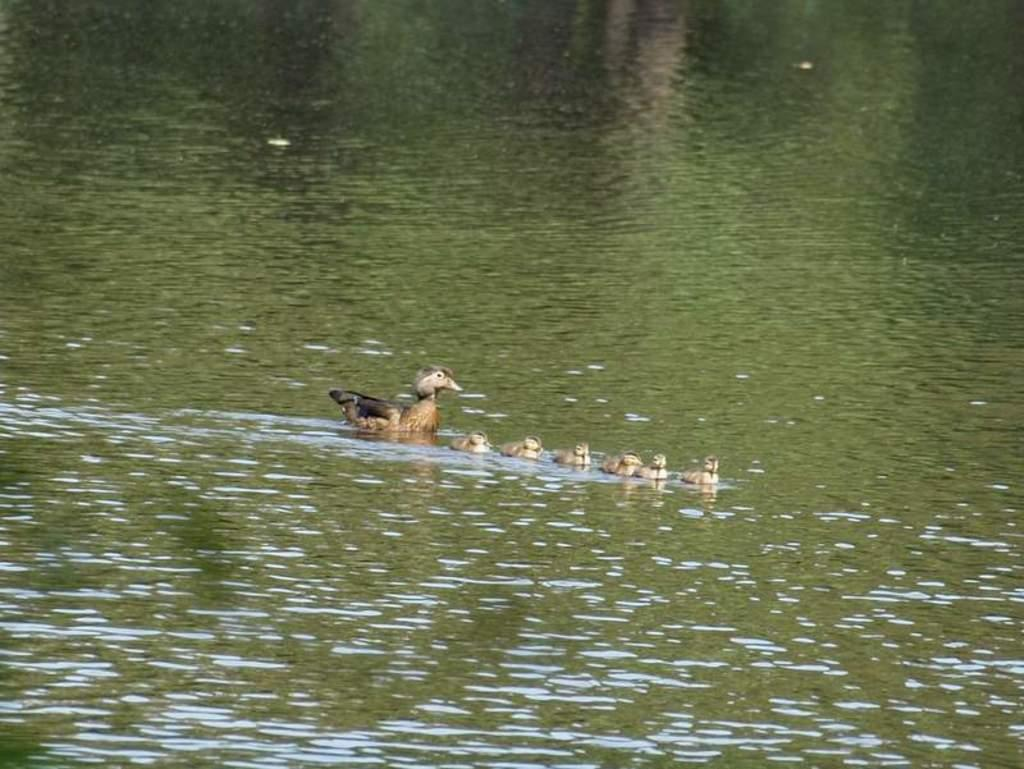What is the main subject of the image? The main subject of the image is birds. Can you describe the appearance of the birds? The birds are in black and brown color. What can be seen in the background of the image? There is water visible in the background of the image. What type of berry is being used as a perch for the birds in the image? There is no berry present in the image; the birds are simply flying or standing in the air. 